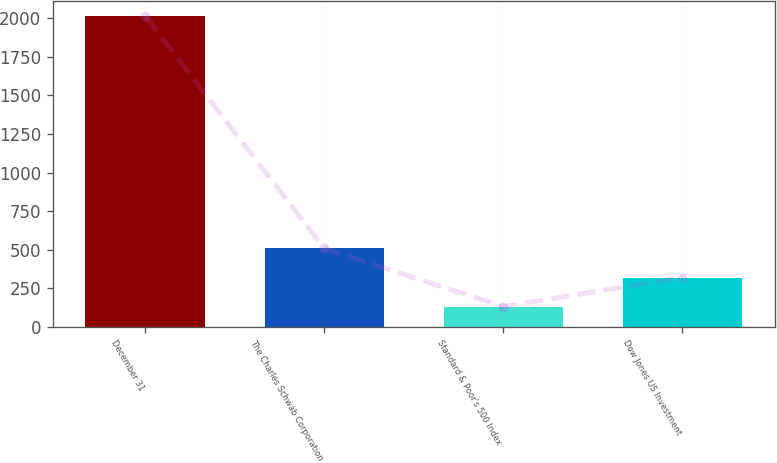Convert chart. <chart><loc_0><loc_0><loc_500><loc_500><bar_chart><fcel>December 31<fcel>The Charles Schwab Corporation<fcel>Standard & Poor's 500 Index<fcel>Dow Jones US Investment<nl><fcel>2013<fcel>508.2<fcel>132<fcel>320.1<nl></chart> 